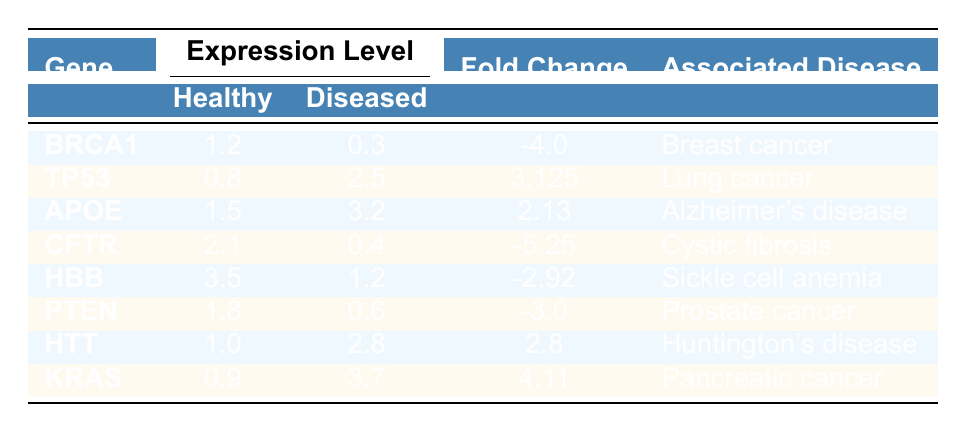What is the expression level of gene BRCA1 in healthy tissue? The table indicates that the expression level of gene BRCA1 in healthy tissue is 1.2.
Answer: 1.2 What is the fold change of gene APOE? The table shows that the fold change of gene APOE is 2.13.
Answer: 2.13 Is the expression level of gene TP53 higher in diseased tissue compared to healthy tissue? The diseased tissue expression of gene TP53 is 2.5, which is higher than its healthy tissue expression of 0.8, confirming that it is higher in diseased tissue.
Answer: Yes What is the average expression level of healthy tissue across all genes listed? To calculate the average, we sum the healthy tissue expression levels: (1.2 + 0.8 + 1.5 + 2.1 + 3.5 + 1.8 + 1.0 + 0.9) = 12.0. There are 8 genes, so the average is 12.0 / 8 = 1.5.
Answer: 1.5 Which gene has the highest expression level in healthy tissue? By reviewing the table, HBB has the highest expression level at 3.5 in healthy tissue.
Answer: HBB How many genes have a fold change less than zero? The genes with a fold change less than zero are BRCA1, CFTR, HBB, and PTEN, totaling 4 genes.
Answer: 4 What is the difference in expression level of gene CFTR between diseased and healthy tissues? The expression level of CFTR in diseased tissue is 0.4, and in healthy tissue, it is 2.1. The difference is 2.1 - 0.4 = 1.7.
Answer: 1.7 Does gene KRAS show a positive or negative fold change? The table states that gene KRAS has a fold change of 4.11, which is positive.
Answer: Positive What is the total expression level in diseased tissues across all genes? The total expression in diseased tissues is calculated by summing the diseased tissue values: (0.3 + 2.5 + 3.2 + 0.4 + 1.2 + 0.6 + 2.8 + 3.7) = 14.7.
Answer: 14.7 